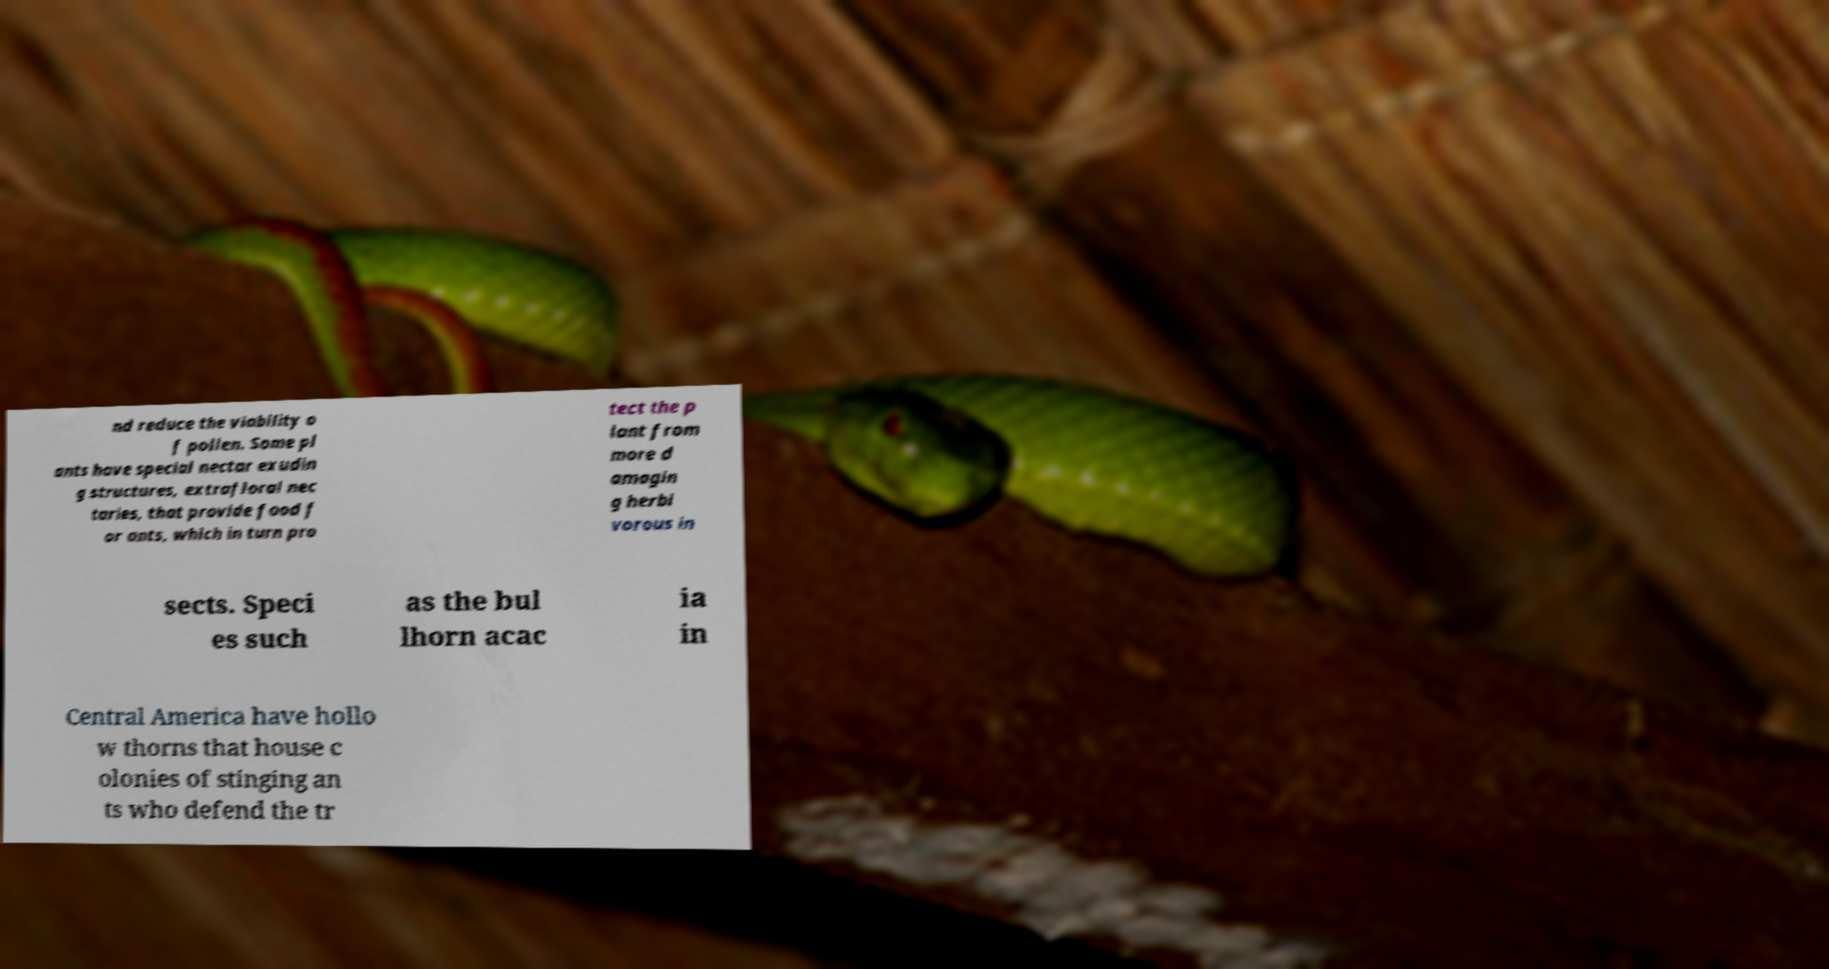Can you accurately transcribe the text from the provided image for me? nd reduce the viability o f pollen. Some pl ants have special nectar exudin g structures, extrafloral nec taries, that provide food f or ants, which in turn pro tect the p lant from more d amagin g herbi vorous in sects. Speci es such as the bul lhorn acac ia in Central America have hollo w thorns that house c olonies of stinging an ts who defend the tr 